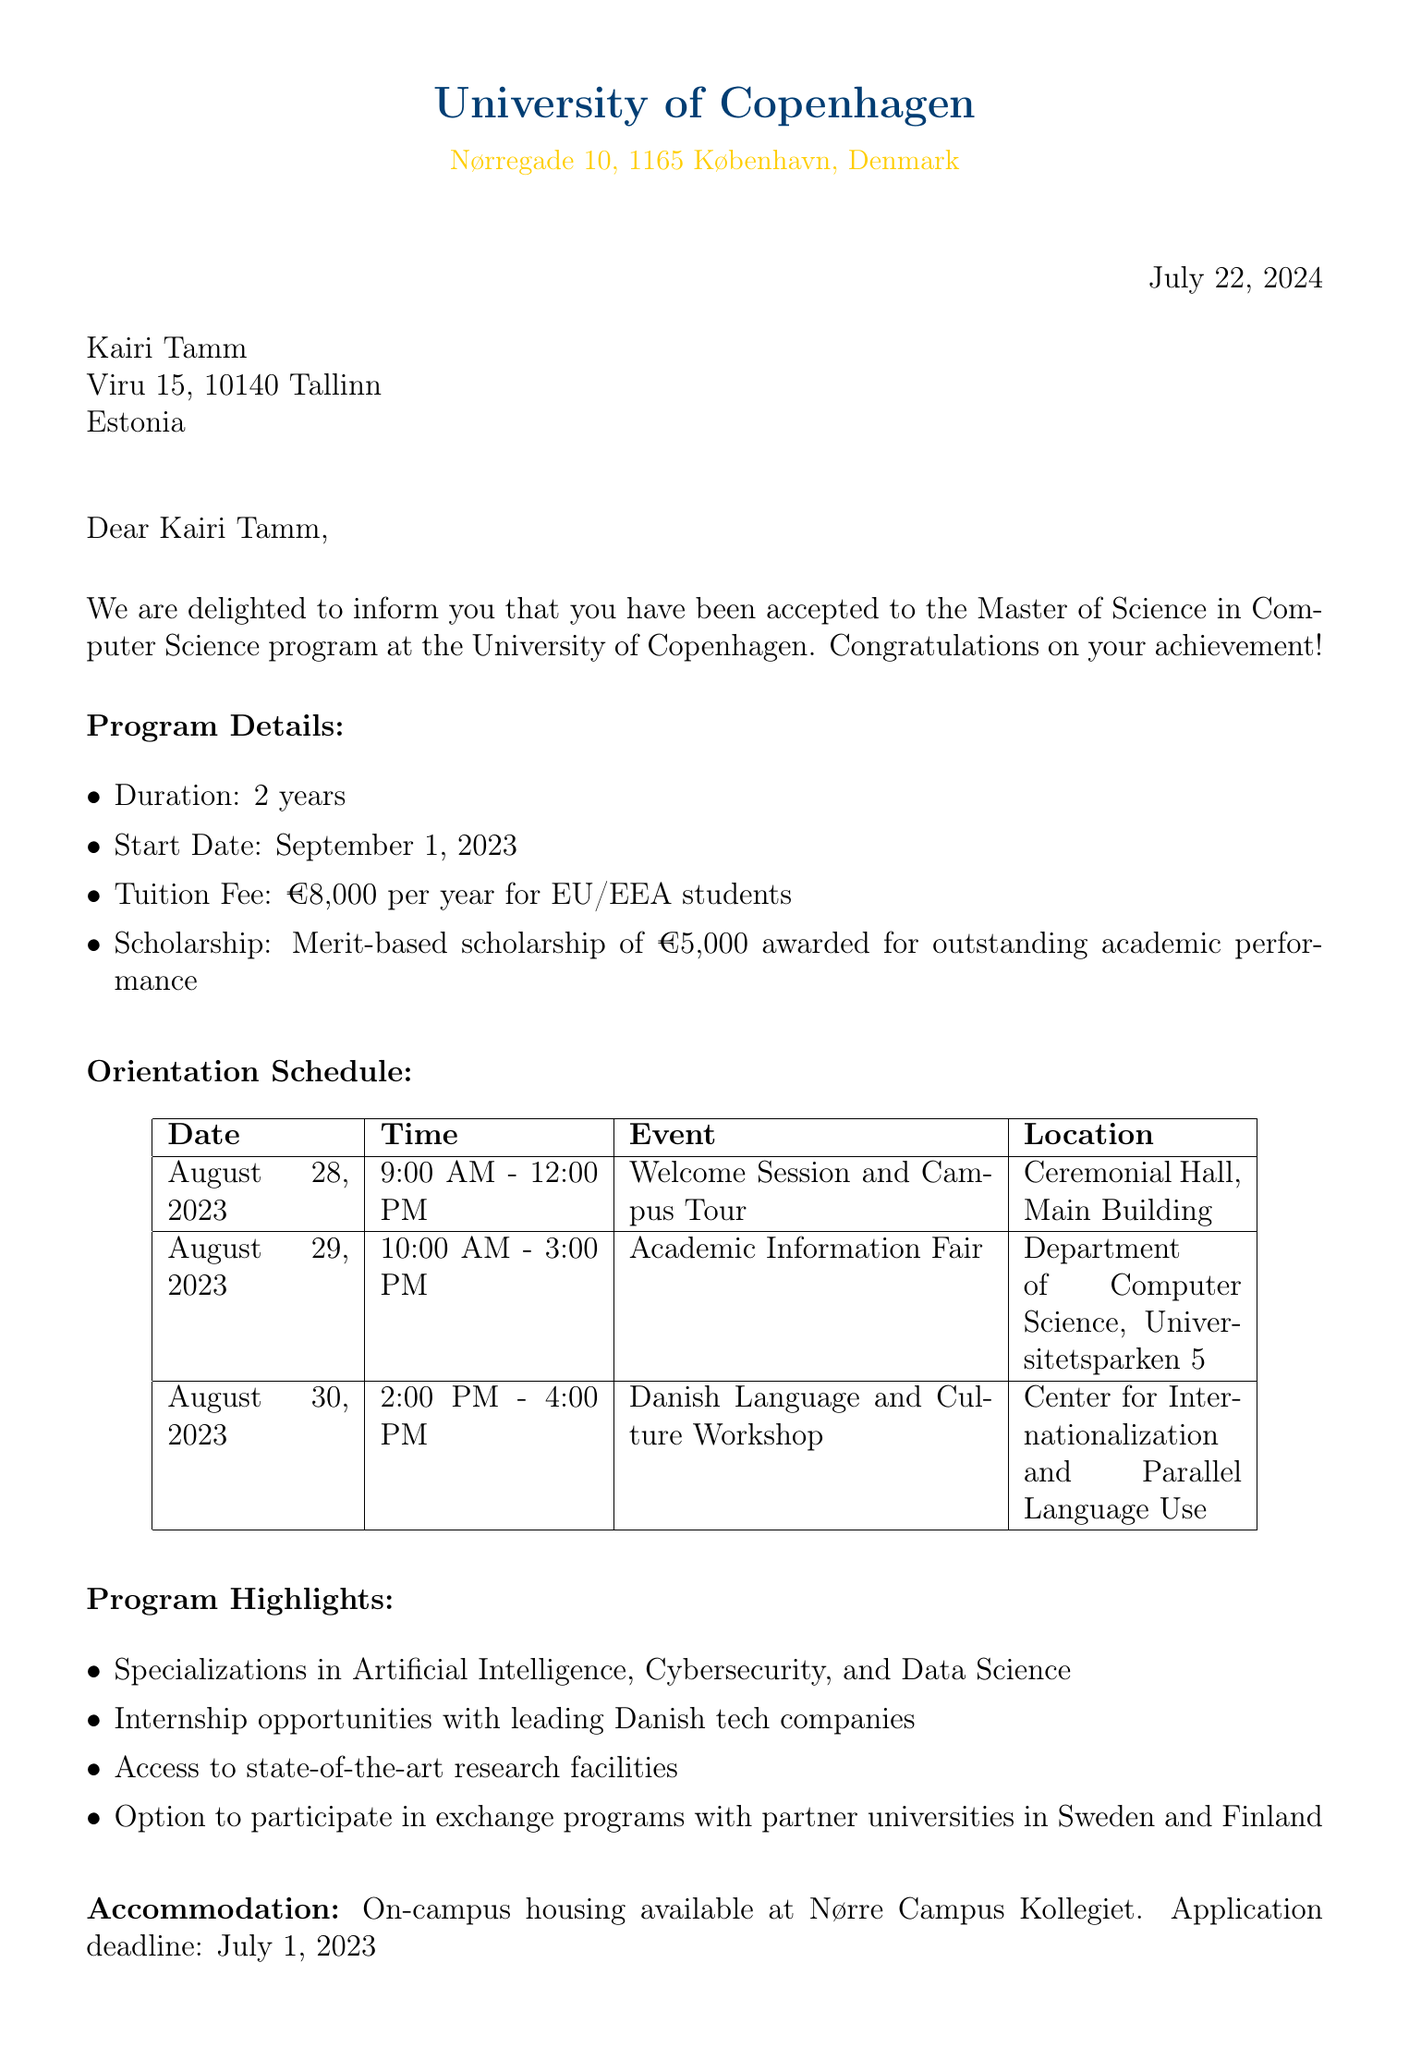What is the name of the university? The name of the university is stated in the letter header as the sender, which is the University of Copenhagen.
Answer: University of Copenhagen What is the duration of the program? The duration of the program is explicitly mentioned in the document under "Program Details."
Answer: 2 years When does the program start? The starting date of the program is a specific detail included in the "Program Details" section of the letter.
Answer: September 1, 2023 What is the tuition fee for EU/EEA students? The tuition fee is clearly listed in the "Program Details" section.
Answer: €8,000 per year What event is scheduled for August 28, 2023? The document includes a detailed orientation schedule with specific events and their dates.
Answer: Welcome Session and Campus Tour Who should be contacted for questions? The document specifies a contact person along with their email address for further inquiries, which is directed to Dr. Lars Hansen.
Answer: Dr. Lars Hansen What is the application deadline for accommodation? The deadline for accommodation is mentioned in the letter under "Accommodation."
Answer: July 1, 2023 What scholarship is available for outstanding academic performance? The letter outlines scholarship information within the program details and specifies the type of scholarship available.
Answer: Merit-based scholarship of €5,000 What are the required documents for enrollment? The letter lists the essential documents needed for enrollment, which are outlined in the "Required Documents" section.
Answer: Signed acceptance form, Copy of passport, Proof of English proficiency, Official transcripts from your bachelor's degree 